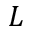Convert formula to latex. <formula><loc_0><loc_0><loc_500><loc_500>L</formula> 